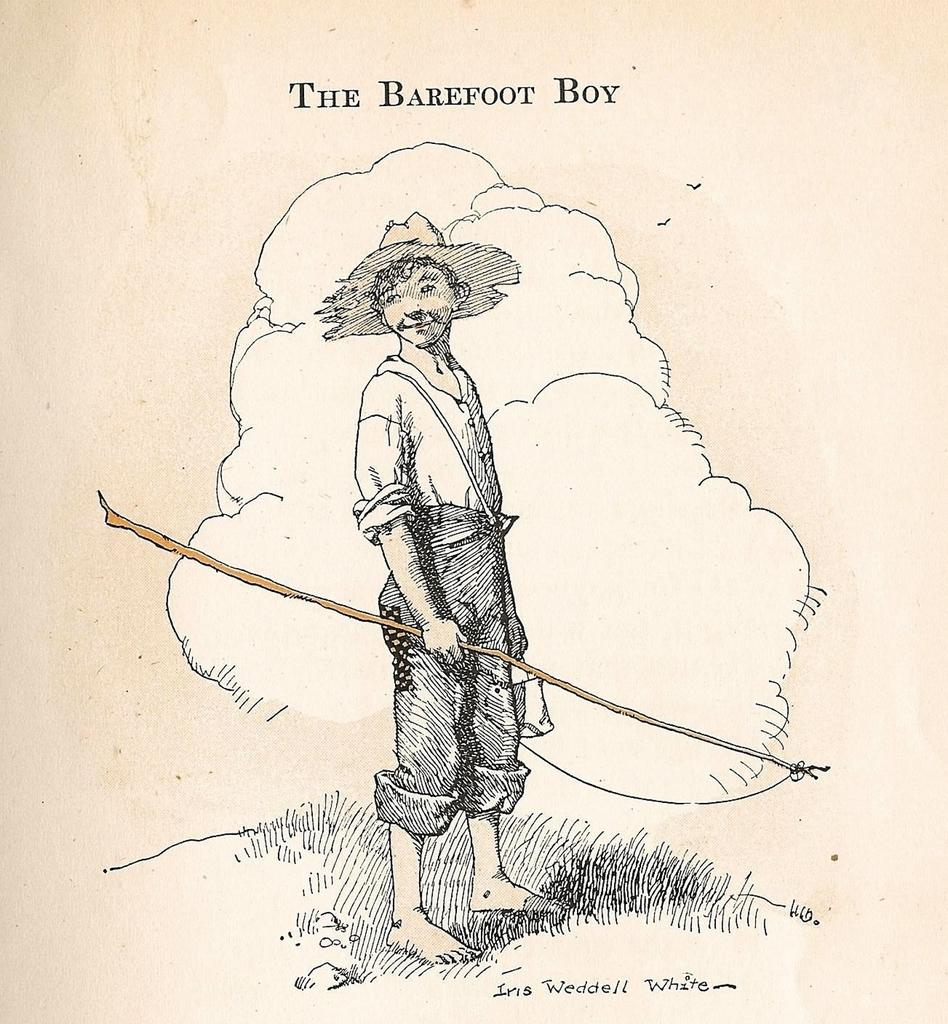What is depicted on the poster in the image? The poster features a man. What is the man wearing in the image? The man is wearing a hat, a shirt, and trousers. What is the man holding in the image? The man is holding a stick. Is there any text on the poster besides the image of the man? Yes, there is a quotation at the top of the poster. What type of music can be heard playing in the background of the image? There is no music playing in the background of the image; it is a static poster featuring a man. Is there a bookshelf visible in the image? No, there is no bookshelf visible in the image; it only features a poster with a man and a quotation. 